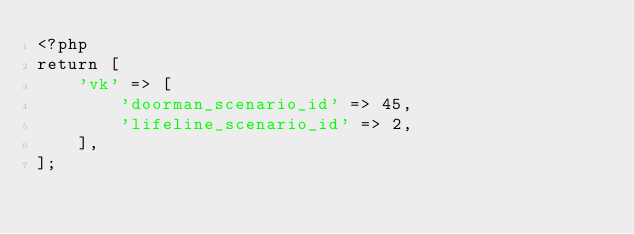<code> <loc_0><loc_0><loc_500><loc_500><_PHP_><?php
return [
    'vk' => [
        'doorman_scenario_id' => 45,
        'lifeline_scenario_id' => 2,
    ],
];</code> 